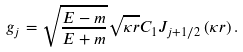<formula> <loc_0><loc_0><loc_500><loc_500>g _ { j } = \sqrt { \frac { E - m } { E + m } } \sqrt { \kappa r } C _ { 1 } J _ { j + 1 / 2 } \left ( \kappa r \right ) .</formula> 